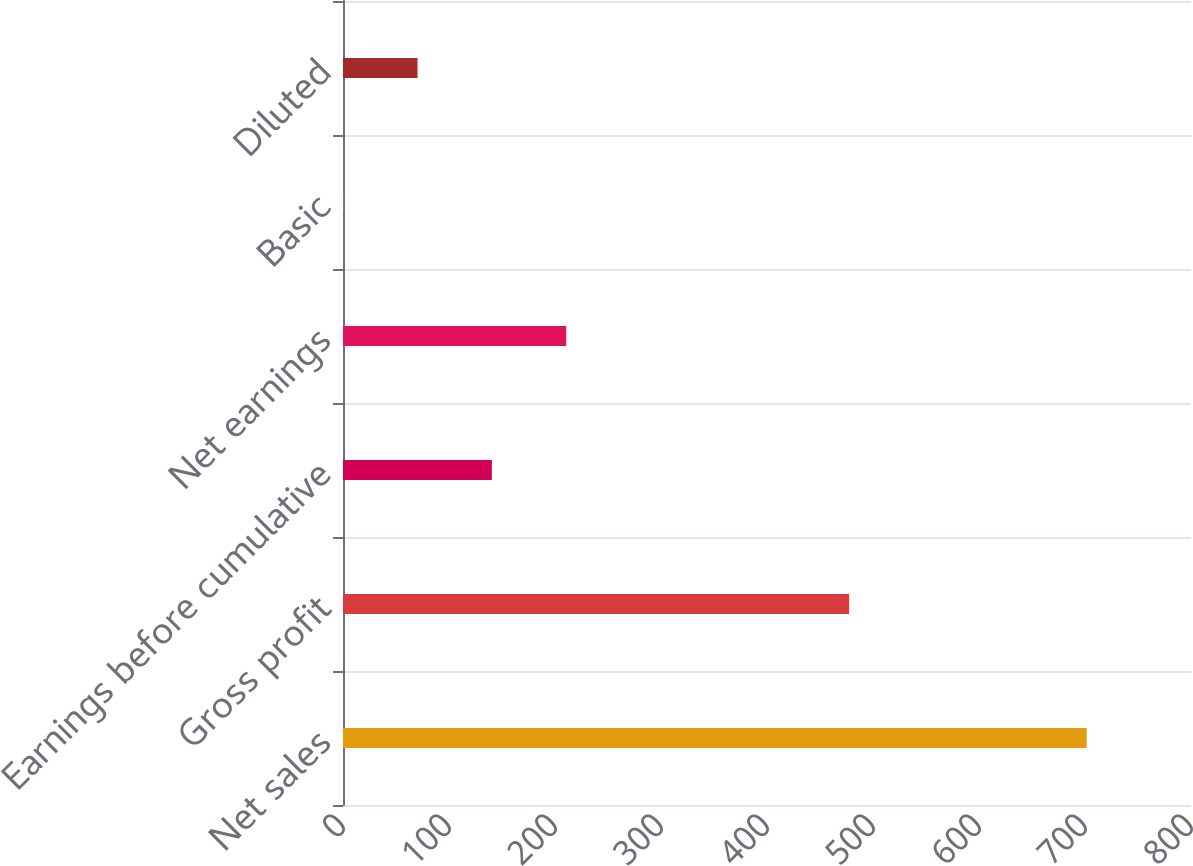Convert chart to OTSL. <chart><loc_0><loc_0><loc_500><loc_500><bar_chart><fcel>Net sales<fcel>Gross profit<fcel>Earnings before cumulative<fcel>Net earnings<fcel>Basic<fcel>Diluted<nl><fcel>701.6<fcel>477.5<fcel>140.44<fcel>210.59<fcel>0.15<fcel>70.3<nl></chart> 